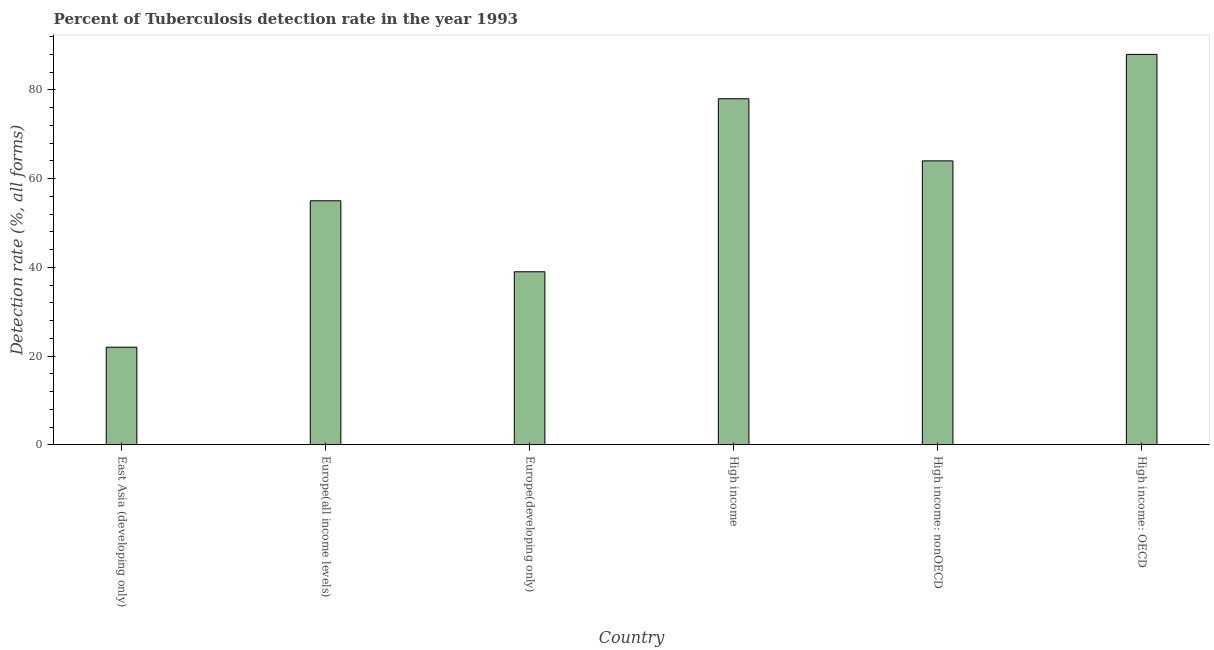Does the graph contain any zero values?
Your answer should be compact. No. Does the graph contain grids?
Offer a very short reply. No. What is the title of the graph?
Make the answer very short. Percent of Tuberculosis detection rate in the year 1993. What is the label or title of the Y-axis?
Offer a very short reply. Detection rate (%, all forms). What is the detection rate of tuberculosis in High income: OECD?
Your response must be concise. 88. Across all countries, what is the maximum detection rate of tuberculosis?
Provide a succinct answer. 88. In which country was the detection rate of tuberculosis maximum?
Give a very brief answer. High income: OECD. In which country was the detection rate of tuberculosis minimum?
Offer a terse response. East Asia (developing only). What is the sum of the detection rate of tuberculosis?
Your answer should be compact. 346. What is the average detection rate of tuberculosis per country?
Make the answer very short. 57.67. What is the median detection rate of tuberculosis?
Provide a succinct answer. 59.5. What is the ratio of the detection rate of tuberculosis in High income: OECD to that in High income: nonOECD?
Your answer should be compact. 1.38. Is the detection rate of tuberculosis in Europe(all income levels) less than that in High income: OECD?
Provide a succinct answer. Yes. What is the difference between the highest and the second highest detection rate of tuberculosis?
Keep it short and to the point. 10. Is the sum of the detection rate of tuberculosis in East Asia (developing only) and Europe(developing only) greater than the maximum detection rate of tuberculosis across all countries?
Offer a terse response. No. What is the Detection rate (%, all forms) of Europe(all income levels)?
Make the answer very short. 55. What is the Detection rate (%, all forms) of High income?
Keep it short and to the point. 78. What is the Detection rate (%, all forms) in High income: nonOECD?
Offer a very short reply. 64. What is the Detection rate (%, all forms) of High income: OECD?
Your answer should be very brief. 88. What is the difference between the Detection rate (%, all forms) in East Asia (developing only) and Europe(all income levels)?
Offer a terse response. -33. What is the difference between the Detection rate (%, all forms) in East Asia (developing only) and Europe(developing only)?
Provide a short and direct response. -17. What is the difference between the Detection rate (%, all forms) in East Asia (developing only) and High income?
Provide a succinct answer. -56. What is the difference between the Detection rate (%, all forms) in East Asia (developing only) and High income: nonOECD?
Make the answer very short. -42. What is the difference between the Detection rate (%, all forms) in East Asia (developing only) and High income: OECD?
Your answer should be compact. -66. What is the difference between the Detection rate (%, all forms) in Europe(all income levels) and High income: nonOECD?
Make the answer very short. -9. What is the difference between the Detection rate (%, all forms) in Europe(all income levels) and High income: OECD?
Offer a very short reply. -33. What is the difference between the Detection rate (%, all forms) in Europe(developing only) and High income?
Your response must be concise. -39. What is the difference between the Detection rate (%, all forms) in Europe(developing only) and High income: OECD?
Provide a short and direct response. -49. What is the ratio of the Detection rate (%, all forms) in East Asia (developing only) to that in Europe(developing only)?
Offer a very short reply. 0.56. What is the ratio of the Detection rate (%, all forms) in East Asia (developing only) to that in High income?
Offer a terse response. 0.28. What is the ratio of the Detection rate (%, all forms) in East Asia (developing only) to that in High income: nonOECD?
Offer a very short reply. 0.34. What is the ratio of the Detection rate (%, all forms) in East Asia (developing only) to that in High income: OECD?
Ensure brevity in your answer.  0.25. What is the ratio of the Detection rate (%, all forms) in Europe(all income levels) to that in Europe(developing only)?
Provide a short and direct response. 1.41. What is the ratio of the Detection rate (%, all forms) in Europe(all income levels) to that in High income?
Your answer should be very brief. 0.7. What is the ratio of the Detection rate (%, all forms) in Europe(all income levels) to that in High income: nonOECD?
Your response must be concise. 0.86. What is the ratio of the Detection rate (%, all forms) in Europe(developing only) to that in High income?
Provide a short and direct response. 0.5. What is the ratio of the Detection rate (%, all forms) in Europe(developing only) to that in High income: nonOECD?
Your response must be concise. 0.61. What is the ratio of the Detection rate (%, all forms) in Europe(developing only) to that in High income: OECD?
Your response must be concise. 0.44. What is the ratio of the Detection rate (%, all forms) in High income to that in High income: nonOECD?
Your answer should be very brief. 1.22. What is the ratio of the Detection rate (%, all forms) in High income to that in High income: OECD?
Provide a succinct answer. 0.89. What is the ratio of the Detection rate (%, all forms) in High income: nonOECD to that in High income: OECD?
Ensure brevity in your answer.  0.73. 